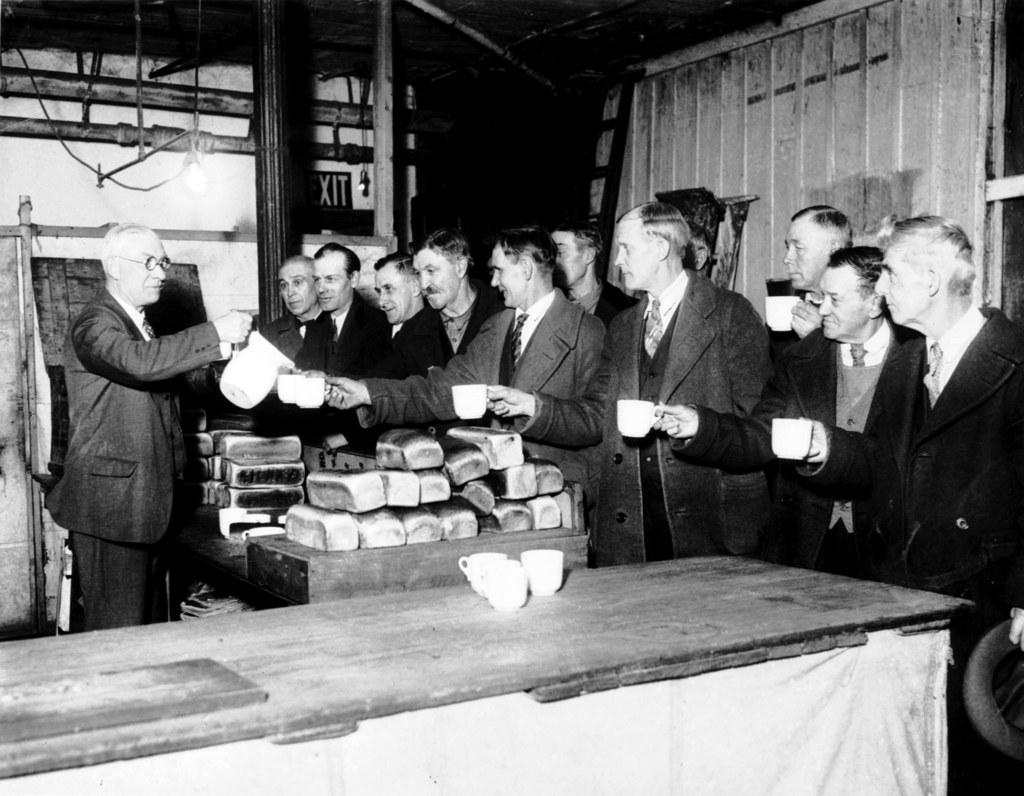What is happening in the image involving a group of people? There is a group of people in the image, and they are standing. What are the people holding in their hands? The people are holding cups in their hands. Is there anyone in the image holding something other than a cup? Yes, there is a man holding a jug in the image. What type of straw is the man using to compete with others in the image? There is no straw or competition present in the image; the man is simply holding a jug. How much money can be seen in the image? There is no mention of money, specifically a dime, in the image. 